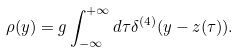Convert formula to latex. <formula><loc_0><loc_0><loc_500><loc_500>\rho ( y ) = g \int _ { - \infty } ^ { + \infty } d \tau \delta ^ { ( 4 ) } ( y - z ( \tau ) ) .</formula> 